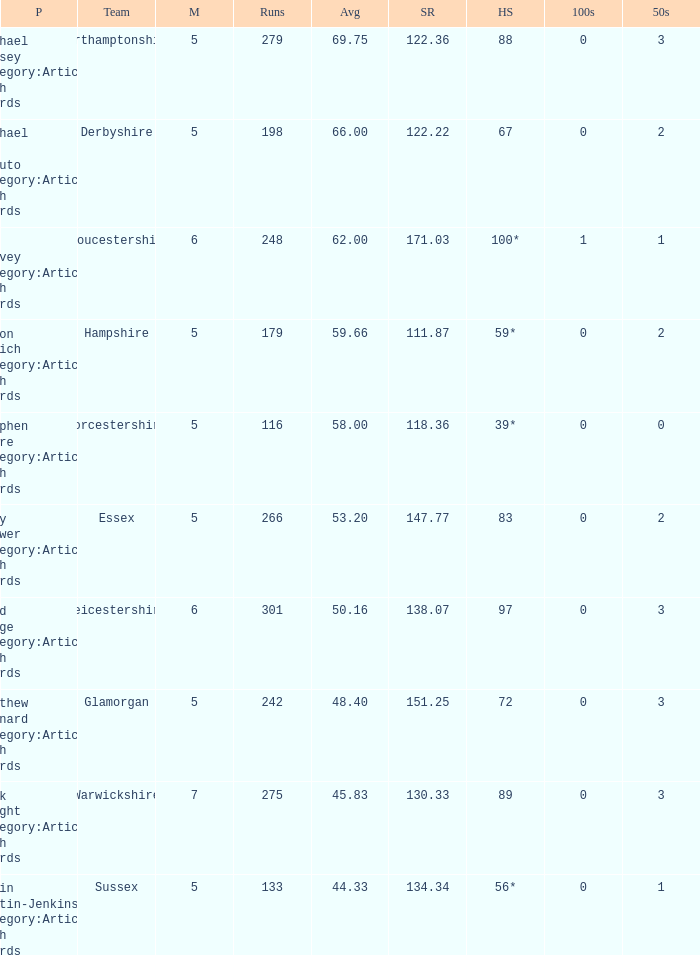If the average is 50.16, who is the player? Brad Hodge Category:Articles with hCards. 